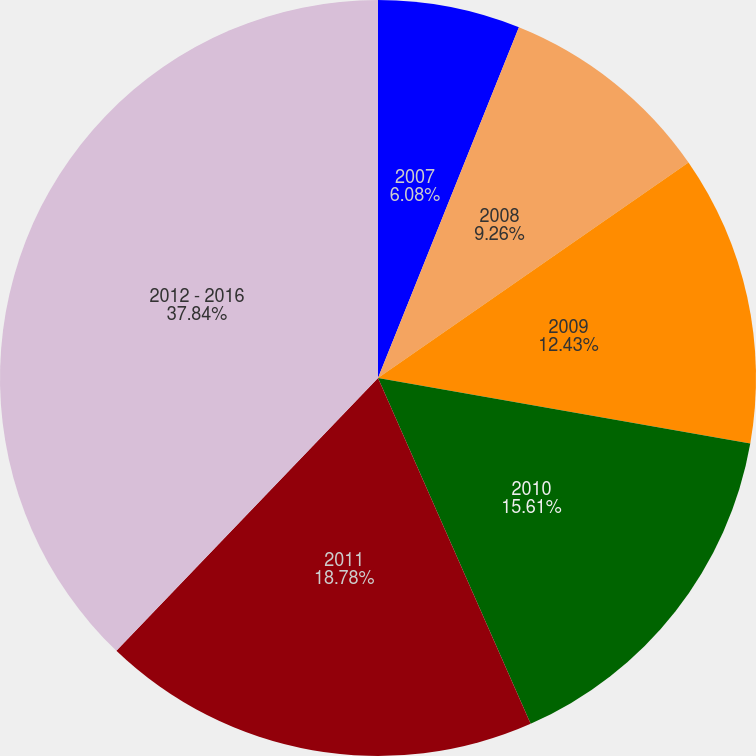Convert chart. <chart><loc_0><loc_0><loc_500><loc_500><pie_chart><fcel>2007<fcel>2008<fcel>2009<fcel>2010<fcel>2011<fcel>2012 - 2016<nl><fcel>6.08%<fcel>9.26%<fcel>12.43%<fcel>15.61%<fcel>18.78%<fcel>37.83%<nl></chart> 